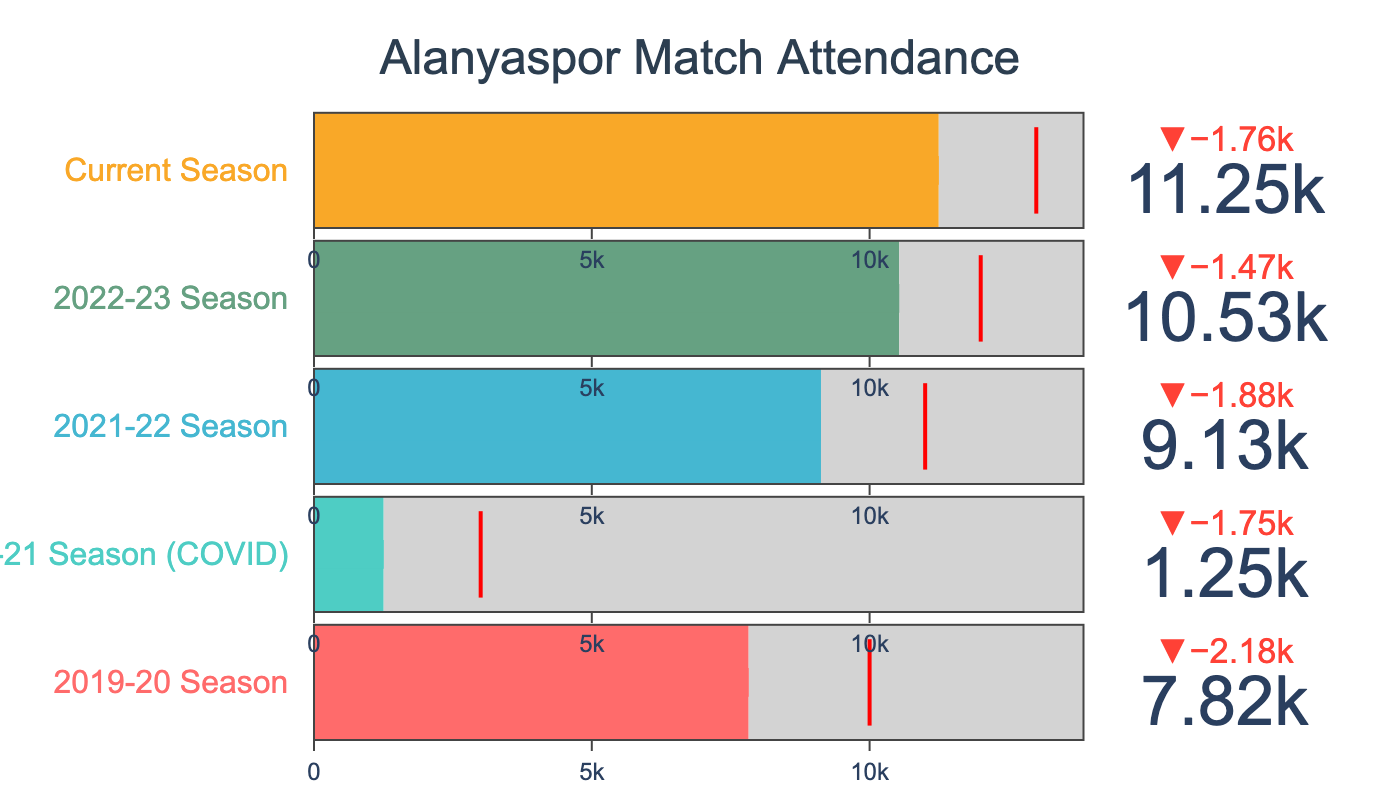What's the title of the figure? The title is usually displayed at the top of the figure. Here, it reads "Alanyaspor Match Attendance."
Answer: "Alanyaspor Match Attendance" How many categories are represented in the figure? Each category corresponds to a season listed on the vertical axis. There are five unique seasons shown.
Answer: 5 What season had the lowest actual attendance? The figure shows the actual attendance values for each season. The 2020-21 Season (COVID) has the lowest, at 1254.
Answer: 2020-21 Season (COVID) How does the current season's actual attendance compare to its target attendance? Compare the actual attendance bar to the target attendance mark for the "Current Season." Actual attendance is 11245, while the target is 13000.
Answer: The actual is lower than the target Which season had the highest actual attendance? Look for the tallest bar representing actual attendance among all seasons. The "Current Season" has the highest attendance, which is 11245.
Answer: Current Season What's the difference between the maximum capacity and the actual attendance for the 2021-22 season? Subtract the actual attendance from the maximum capacity for the 2021-22 season (13850 - 9125).
Answer: 4725 By how much did the actual attendance increase from the 2021-22 season to the 2022-23 season? Subtract the actual attendance of the 2021-22 season from the 2022-23 season (10534 - 9125).
Answer: 1409 Which season came closest to meeting its target attendance? Find the season with the smallest gap between actual attendance and its target. The 2022-23 Season had an actual of 10534 and a target of 12000 with a gap of 1466, which is the smallest compared to other seasons.
Answer: 2022-23 Season What color represents the 2019-20 Season? The figure uses different colors for each season. The 2019-20 Season is indicated by a red bar.
Answer: Red What's the average actual attendance over all the seasons? Add up the actual attendances for all seasons (7823 + 1254 + 9125 + 10534 + 11245) and divide by the number of seasons (5). It calculates to 39981/5 = 7996.2
Answer: 7996.2 